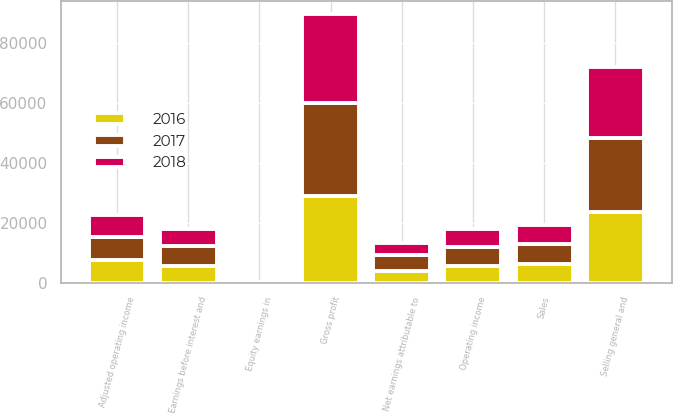Convert chart to OTSL. <chart><loc_0><loc_0><loc_500><loc_500><stacked_bar_chart><ecel><fcel>Sales<fcel>Gross profit<fcel>Selling general and<fcel>Equity earnings in<fcel>Operating income<fcel>Adjusted operating income<fcel>Earnings before interest and<fcel>Net earnings attributable to<nl><fcel>2017<fcel>6414<fcel>30792<fcel>24569<fcel>191<fcel>6414<fcel>7804<fcel>6591<fcel>5024<nl><fcel>2016<fcel>6414<fcel>29162<fcel>23740<fcel>135<fcel>5557<fcel>7540<fcel>5546<fcel>4078<nl><fcel>2018<fcel>6414<fcel>29874<fcel>23910<fcel>37<fcel>6001<fcel>7208<fcel>5740<fcel>4173<nl></chart> 